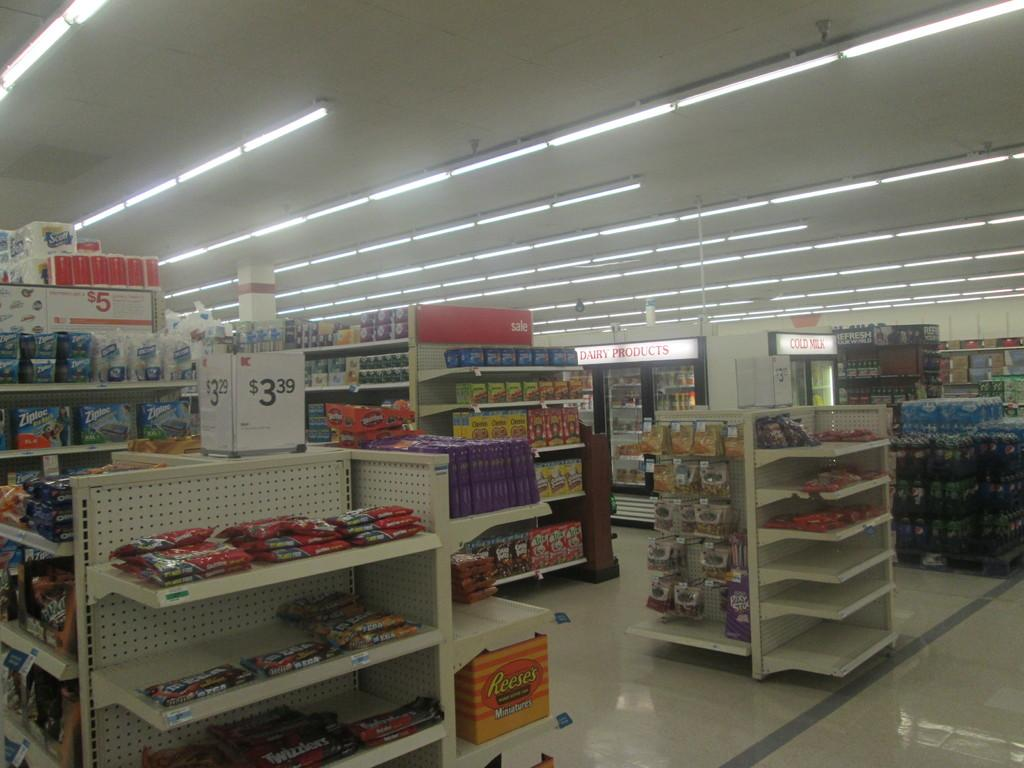Provide a one-sentence caption for the provided image. a store with something that is for sale at 3.39. 